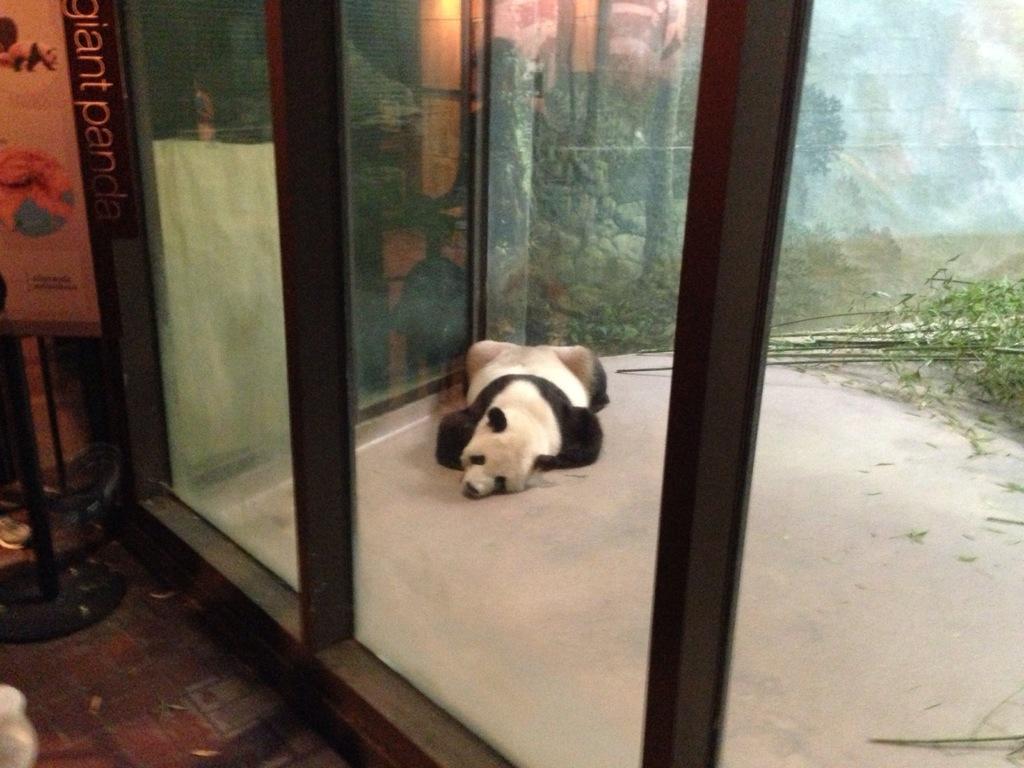In one or two sentences, can you explain what this image depicts? In this image I can see an animal sleeping on the floor and the animal is in white and black color. Background I can see few trees in green color and a glass door. 